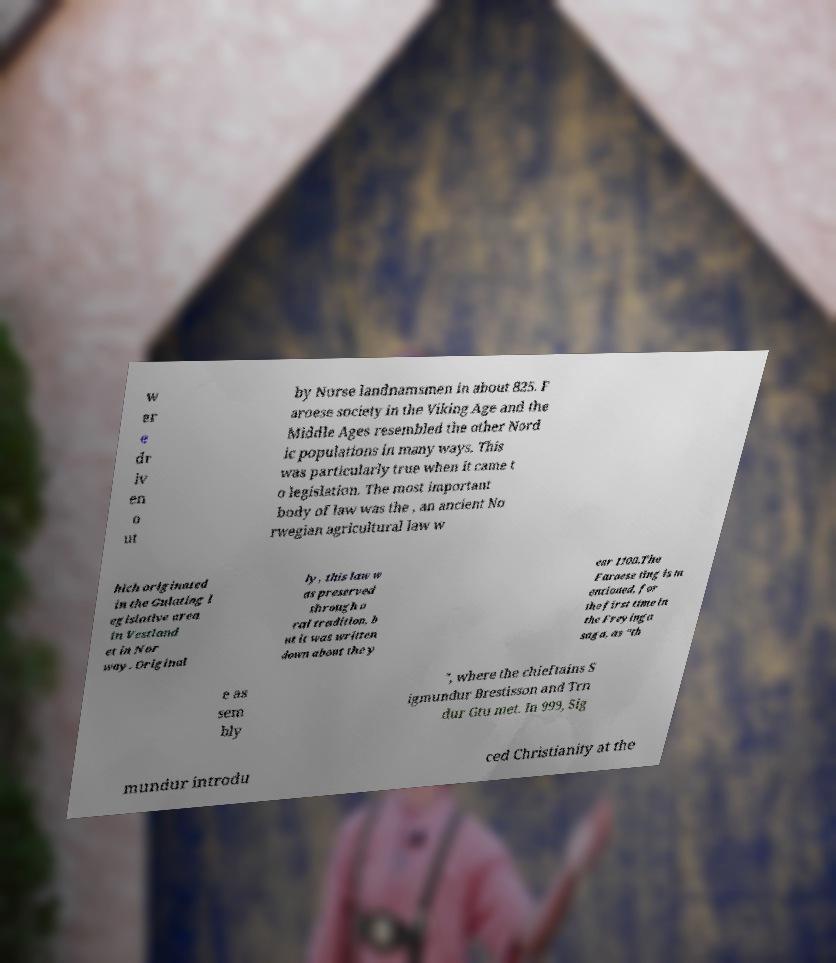Please read and relay the text visible in this image. What does it say? w er e dr iv en o ut by Norse landnamsmen in about 825. F aroese society in the Viking Age and the Middle Ages resembled the other Nord ic populations in many ways. This was particularly true when it came t o legislation. The most important body of law was the , an ancient No rwegian agricultural law w hich originated in the Gulating l egislative area in Vestland et in Nor way. Original ly, this law w as preserved through o ral tradition, b ut it was written down about the y ear 1100.The Faroese ting is m entioned, for the first time in the Freyinga saga, as "th e as sem bly ", where the chieftains S igmundur Brestisson and Trn dur Gtu met. In 999, Sig mundur introdu ced Christianity at the 